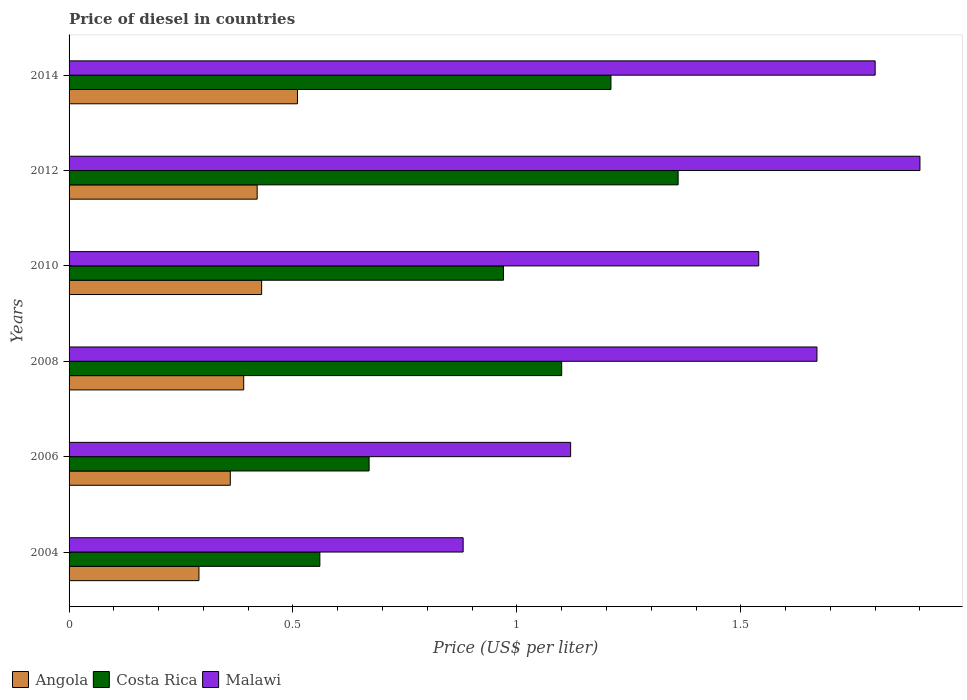How many different coloured bars are there?
Your response must be concise. 3. How many groups of bars are there?
Provide a succinct answer. 6. Are the number of bars per tick equal to the number of legend labels?
Give a very brief answer. Yes. Are the number of bars on each tick of the Y-axis equal?
Make the answer very short. Yes. How many bars are there on the 3rd tick from the bottom?
Your answer should be compact. 3. What is the label of the 4th group of bars from the top?
Provide a short and direct response. 2008. In how many cases, is the number of bars for a given year not equal to the number of legend labels?
Offer a terse response. 0. What is the price of diesel in Malawi in 2010?
Your response must be concise. 1.54. Across all years, what is the maximum price of diesel in Angola?
Offer a very short reply. 0.51. In which year was the price of diesel in Angola maximum?
Provide a succinct answer. 2014. What is the total price of diesel in Angola in the graph?
Offer a terse response. 2.4. What is the difference between the price of diesel in Malawi in 2006 and that in 2012?
Offer a very short reply. -0.78. What is the difference between the price of diesel in Malawi in 2006 and the price of diesel in Angola in 2010?
Make the answer very short. 0.69. What is the average price of diesel in Costa Rica per year?
Offer a very short reply. 0.98. In the year 2014, what is the difference between the price of diesel in Malawi and price of diesel in Costa Rica?
Give a very brief answer. 0.59. What is the ratio of the price of diesel in Costa Rica in 2008 to that in 2010?
Make the answer very short. 1.13. Is the price of diesel in Angola in 2004 less than that in 2012?
Your answer should be very brief. Yes. What is the difference between the highest and the second highest price of diesel in Malawi?
Provide a short and direct response. 0.1. In how many years, is the price of diesel in Angola greater than the average price of diesel in Angola taken over all years?
Offer a very short reply. 3. Is the sum of the price of diesel in Costa Rica in 2004 and 2006 greater than the maximum price of diesel in Angola across all years?
Provide a succinct answer. Yes. What does the 3rd bar from the top in 2004 represents?
Your answer should be compact. Angola. What does the 2nd bar from the bottom in 2012 represents?
Keep it short and to the point. Costa Rica. Is it the case that in every year, the sum of the price of diesel in Costa Rica and price of diesel in Angola is greater than the price of diesel in Malawi?
Give a very brief answer. No. How many bars are there?
Keep it short and to the point. 18. How many years are there in the graph?
Provide a short and direct response. 6. Are the values on the major ticks of X-axis written in scientific E-notation?
Offer a very short reply. No. Does the graph contain grids?
Provide a short and direct response. No. Where does the legend appear in the graph?
Provide a succinct answer. Bottom left. What is the title of the graph?
Make the answer very short. Price of diesel in countries. Does "Low & middle income" appear as one of the legend labels in the graph?
Give a very brief answer. No. What is the label or title of the X-axis?
Provide a short and direct response. Price (US$ per liter). What is the Price (US$ per liter) of Angola in 2004?
Provide a short and direct response. 0.29. What is the Price (US$ per liter) in Costa Rica in 2004?
Keep it short and to the point. 0.56. What is the Price (US$ per liter) of Malawi in 2004?
Keep it short and to the point. 0.88. What is the Price (US$ per liter) in Angola in 2006?
Keep it short and to the point. 0.36. What is the Price (US$ per liter) in Costa Rica in 2006?
Your answer should be compact. 0.67. What is the Price (US$ per liter) in Malawi in 2006?
Provide a succinct answer. 1.12. What is the Price (US$ per liter) of Angola in 2008?
Your answer should be compact. 0.39. What is the Price (US$ per liter) in Malawi in 2008?
Provide a succinct answer. 1.67. What is the Price (US$ per liter) of Angola in 2010?
Your response must be concise. 0.43. What is the Price (US$ per liter) in Malawi in 2010?
Offer a terse response. 1.54. What is the Price (US$ per liter) in Angola in 2012?
Your response must be concise. 0.42. What is the Price (US$ per liter) of Costa Rica in 2012?
Keep it short and to the point. 1.36. What is the Price (US$ per liter) in Angola in 2014?
Make the answer very short. 0.51. What is the Price (US$ per liter) of Costa Rica in 2014?
Offer a terse response. 1.21. What is the Price (US$ per liter) in Malawi in 2014?
Give a very brief answer. 1.8. Across all years, what is the maximum Price (US$ per liter) in Angola?
Your answer should be very brief. 0.51. Across all years, what is the maximum Price (US$ per liter) of Costa Rica?
Provide a short and direct response. 1.36. Across all years, what is the minimum Price (US$ per liter) in Angola?
Ensure brevity in your answer.  0.29. Across all years, what is the minimum Price (US$ per liter) of Costa Rica?
Provide a short and direct response. 0.56. Across all years, what is the minimum Price (US$ per liter) in Malawi?
Provide a succinct answer. 0.88. What is the total Price (US$ per liter) in Angola in the graph?
Your answer should be very brief. 2.4. What is the total Price (US$ per liter) in Costa Rica in the graph?
Your answer should be very brief. 5.87. What is the total Price (US$ per liter) of Malawi in the graph?
Give a very brief answer. 8.91. What is the difference between the Price (US$ per liter) of Angola in 2004 and that in 2006?
Offer a terse response. -0.07. What is the difference between the Price (US$ per liter) of Costa Rica in 2004 and that in 2006?
Provide a short and direct response. -0.11. What is the difference between the Price (US$ per liter) of Malawi in 2004 and that in 2006?
Keep it short and to the point. -0.24. What is the difference between the Price (US$ per liter) of Angola in 2004 and that in 2008?
Offer a terse response. -0.1. What is the difference between the Price (US$ per liter) of Costa Rica in 2004 and that in 2008?
Give a very brief answer. -0.54. What is the difference between the Price (US$ per liter) in Malawi in 2004 and that in 2008?
Provide a succinct answer. -0.79. What is the difference between the Price (US$ per liter) in Angola in 2004 and that in 2010?
Offer a terse response. -0.14. What is the difference between the Price (US$ per liter) in Costa Rica in 2004 and that in 2010?
Your answer should be compact. -0.41. What is the difference between the Price (US$ per liter) in Malawi in 2004 and that in 2010?
Your answer should be very brief. -0.66. What is the difference between the Price (US$ per liter) of Angola in 2004 and that in 2012?
Offer a very short reply. -0.13. What is the difference between the Price (US$ per liter) of Costa Rica in 2004 and that in 2012?
Keep it short and to the point. -0.8. What is the difference between the Price (US$ per liter) of Malawi in 2004 and that in 2012?
Make the answer very short. -1.02. What is the difference between the Price (US$ per liter) of Angola in 2004 and that in 2014?
Ensure brevity in your answer.  -0.22. What is the difference between the Price (US$ per liter) in Costa Rica in 2004 and that in 2014?
Your answer should be compact. -0.65. What is the difference between the Price (US$ per liter) of Malawi in 2004 and that in 2014?
Offer a very short reply. -0.92. What is the difference between the Price (US$ per liter) in Angola in 2006 and that in 2008?
Your response must be concise. -0.03. What is the difference between the Price (US$ per liter) in Costa Rica in 2006 and that in 2008?
Keep it short and to the point. -0.43. What is the difference between the Price (US$ per liter) in Malawi in 2006 and that in 2008?
Make the answer very short. -0.55. What is the difference between the Price (US$ per liter) of Angola in 2006 and that in 2010?
Make the answer very short. -0.07. What is the difference between the Price (US$ per liter) in Costa Rica in 2006 and that in 2010?
Ensure brevity in your answer.  -0.3. What is the difference between the Price (US$ per liter) in Malawi in 2006 and that in 2010?
Offer a very short reply. -0.42. What is the difference between the Price (US$ per liter) of Angola in 2006 and that in 2012?
Make the answer very short. -0.06. What is the difference between the Price (US$ per liter) of Costa Rica in 2006 and that in 2012?
Provide a short and direct response. -0.69. What is the difference between the Price (US$ per liter) of Malawi in 2006 and that in 2012?
Your answer should be compact. -0.78. What is the difference between the Price (US$ per liter) of Costa Rica in 2006 and that in 2014?
Give a very brief answer. -0.54. What is the difference between the Price (US$ per liter) in Malawi in 2006 and that in 2014?
Make the answer very short. -0.68. What is the difference between the Price (US$ per liter) of Angola in 2008 and that in 2010?
Offer a very short reply. -0.04. What is the difference between the Price (US$ per liter) in Costa Rica in 2008 and that in 2010?
Make the answer very short. 0.13. What is the difference between the Price (US$ per liter) in Malawi in 2008 and that in 2010?
Offer a very short reply. 0.13. What is the difference between the Price (US$ per liter) in Angola in 2008 and that in 2012?
Provide a short and direct response. -0.03. What is the difference between the Price (US$ per liter) in Costa Rica in 2008 and that in 2012?
Your answer should be very brief. -0.26. What is the difference between the Price (US$ per liter) in Malawi in 2008 and that in 2012?
Your response must be concise. -0.23. What is the difference between the Price (US$ per liter) of Angola in 2008 and that in 2014?
Your answer should be compact. -0.12. What is the difference between the Price (US$ per liter) of Costa Rica in 2008 and that in 2014?
Provide a short and direct response. -0.11. What is the difference between the Price (US$ per liter) of Malawi in 2008 and that in 2014?
Offer a very short reply. -0.13. What is the difference between the Price (US$ per liter) in Angola in 2010 and that in 2012?
Your answer should be compact. 0.01. What is the difference between the Price (US$ per liter) of Costa Rica in 2010 and that in 2012?
Ensure brevity in your answer.  -0.39. What is the difference between the Price (US$ per liter) of Malawi in 2010 and that in 2012?
Ensure brevity in your answer.  -0.36. What is the difference between the Price (US$ per liter) in Angola in 2010 and that in 2014?
Give a very brief answer. -0.08. What is the difference between the Price (US$ per liter) of Costa Rica in 2010 and that in 2014?
Make the answer very short. -0.24. What is the difference between the Price (US$ per liter) in Malawi in 2010 and that in 2014?
Your response must be concise. -0.26. What is the difference between the Price (US$ per liter) of Angola in 2012 and that in 2014?
Offer a very short reply. -0.09. What is the difference between the Price (US$ per liter) in Costa Rica in 2012 and that in 2014?
Ensure brevity in your answer.  0.15. What is the difference between the Price (US$ per liter) of Malawi in 2012 and that in 2014?
Keep it short and to the point. 0.1. What is the difference between the Price (US$ per liter) in Angola in 2004 and the Price (US$ per liter) in Costa Rica in 2006?
Provide a short and direct response. -0.38. What is the difference between the Price (US$ per liter) in Angola in 2004 and the Price (US$ per liter) in Malawi in 2006?
Ensure brevity in your answer.  -0.83. What is the difference between the Price (US$ per liter) in Costa Rica in 2004 and the Price (US$ per liter) in Malawi in 2006?
Your response must be concise. -0.56. What is the difference between the Price (US$ per liter) in Angola in 2004 and the Price (US$ per liter) in Costa Rica in 2008?
Your answer should be very brief. -0.81. What is the difference between the Price (US$ per liter) in Angola in 2004 and the Price (US$ per liter) in Malawi in 2008?
Your response must be concise. -1.38. What is the difference between the Price (US$ per liter) in Costa Rica in 2004 and the Price (US$ per liter) in Malawi in 2008?
Your answer should be compact. -1.11. What is the difference between the Price (US$ per liter) of Angola in 2004 and the Price (US$ per liter) of Costa Rica in 2010?
Ensure brevity in your answer.  -0.68. What is the difference between the Price (US$ per liter) of Angola in 2004 and the Price (US$ per liter) of Malawi in 2010?
Ensure brevity in your answer.  -1.25. What is the difference between the Price (US$ per liter) of Costa Rica in 2004 and the Price (US$ per liter) of Malawi in 2010?
Ensure brevity in your answer.  -0.98. What is the difference between the Price (US$ per liter) of Angola in 2004 and the Price (US$ per liter) of Costa Rica in 2012?
Make the answer very short. -1.07. What is the difference between the Price (US$ per liter) of Angola in 2004 and the Price (US$ per liter) of Malawi in 2012?
Your answer should be compact. -1.61. What is the difference between the Price (US$ per liter) in Costa Rica in 2004 and the Price (US$ per liter) in Malawi in 2012?
Your answer should be compact. -1.34. What is the difference between the Price (US$ per liter) in Angola in 2004 and the Price (US$ per liter) in Costa Rica in 2014?
Provide a short and direct response. -0.92. What is the difference between the Price (US$ per liter) of Angola in 2004 and the Price (US$ per liter) of Malawi in 2014?
Provide a succinct answer. -1.51. What is the difference between the Price (US$ per liter) in Costa Rica in 2004 and the Price (US$ per liter) in Malawi in 2014?
Make the answer very short. -1.24. What is the difference between the Price (US$ per liter) of Angola in 2006 and the Price (US$ per liter) of Costa Rica in 2008?
Make the answer very short. -0.74. What is the difference between the Price (US$ per liter) in Angola in 2006 and the Price (US$ per liter) in Malawi in 2008?
Your response must be concise. -1.31. What is the difference between the Price (US$ per liter) of Angola in 2006 and the Price (US$ per liter) of Costa Rica in 2010?
Your answer should be compact. -0.61. What is the difference between the Price (US$ per liter) of Angola in 2006 and the Price (US$ per liter) of Malawi in 2010?
Your answer should be compact. -1.18. What is the difference between the Price (US$ per liter) of Costa Rica in 2006 and the Price (US$ per liter) of Malawi in 2010?
Keep it short and to the point. -0.87. What is the difference between the Price (US$ per liter) of Angola in 2006 and the Price (US$ per liter) of Costa Rica in 2012?
Your answer should be compact. -1. What is the difference between the Price (US$ per liter) of Angola in 2006 and the Price (US$ per liter) of Malawi in 2012?
Keep it short and to the point. -1.54. What is the difference between the Price (US$ per liter) of Costa Rica in 2006 and the Price (US$ per liter) of Malawi in 2012?
Keep it short and to the point. -1.23. What is the difference between the Price (US$ per liter) in Angola in 2006 and the Price (US$ per liter) in Costa Rica in 2014?
Offer a very short reply. -0.85. What is the difference between the Price (US$ per liter) of Angola in 2006 and the Price (US$ per liter) of Malawi in 2014?
Your answer should be compact. -1.44. What is the difference between the Price (US$ per liter) of Costa Rica in 2006 and the Price (US$ per liter) of Malawi in 2014?
Offer a terse response. -1.13. What is the difference between the Price (US$ per liter) in Angola in 2008 and the Price (US$ per liter) in Costa Rica in 2010?
Make the answer very short. -0.58. What is the difference between the Price (US$ per liter) of Angola in 2008 and the Price (US$ per liter) of Malawi in 2010?
Offer a terse response. -1.15. What is the difference between the Price (US$ per liter) of Costa Rica in 2008 and the Price (US$ per liter) of Malawi in 2010?
Keep it short and to the point. -0.44. What is the difference between the Price (US$ per liter) in Angola in 2008 and the Price (US$ per liter) in Costa Rica in 2012?
Offer a terse response. -0.97. What is the difference between the Price (US$ per liter) of Angola in 2008 and the Price (US$ per liter) of Malawi in 2012?
Ensure brevity in your answer.  -1.51. What is the difference between the Price (US$ per liter) in Angola in 2008 and the Price (US$ per liter) in Costa Rica in 2014?
Keep it short and to the point. -0.82. What is the difference between the Price (US$ per liter) of Angola in 2008 and the Price (US$ per liter) of Malawi in 2014?
Provide a short and direct response. -1.41. What is the difference between the Price (US$ per liter) in Angola in 2010 and the Price (US$ per liter) in Costa Rica in 2012?
Ensure brevity in your answer.  -0.93. What is the difference between the Price (US$ per liter) in Angola in 2010 and the Price (US$ per liter) in Malawi in 2012?
Your response must be concise. -1.47. What is the difference between the Price (US$ per liter) in Costa Rica in 2010 and the Price (US$ per liter) in Malawi in 2012?
Offer a terse response. -0.93. What is the difference between the Price (US$ per liter) of Angola in 2010 and the Price (US$ per liter) of Costa Rica in 2014?
Your response must be concise. -0.78. What is the difference between the Price (US$ per liter) in Angola in 2010 and the Price (US$ per liter) in Malawi in 2014?
Provide a short and direct response. -1.37. What is the difference between the Price (US$ per liter) of Costa Rica in 2010 and the Price (US$ per liter) of Malawi in 2014?
Provide a succinct answer. -0.83. What is the difference between the Price (US$ per liter) of Angola in 2012 and the Price (US$ per liter) of Costa Rica in 2014?
Make the answer very short. -0.79. What is the difference between the Price (US$ per liter) of Angola in 2012 and the Price (US$ per liter) of Malawi in 2014?
Offer a terse response. -1.38. What is the difference between the Price (US$ per liter) in Costa Rica in 2012 and the Price (US$ per liter) in Malawi in 2014?
Keep it short and to the point. -0.44. What is the average Price (US$ per liter) in Angola per year?
Offer a terse response. 0.4. What is the average Price (US$ per liter) in Costa Rica per year?
Make the answer very short. 0.98. What is the average Price (US$ per liter) of Malawi per year?
Offer a very short reply. 1.49. In the year 2004, what is the difference between the Price (US$ per liter) of Angola and Price (US$ per liter) of Costa Rica?
Keep it short and to the point. -0.27. In the year 2004, what is the difference between the Price (US$ per liter) in Angola and Price (US$ per liter) in Malawi?
Make the answer very short. -0.59. In the year 2004, what is the difference between the Price (US$ per liter) in Costa Rica and Price (US$ per liter) in Malawi?
Your response must be concise. -0.32. In the year 2006, what is the difference between the Price (US$ per liter) of Angola and Price (US$ per liter) of Costa Rica?
Your answer should be very brief. -0.31. In the year 2006, what is the difference between the Price (US$ per liter) of Angola and Price (US$ per liter) of Malawi?
Your response must be concise. -0.76. In the year 2006, what is the difference between the Price (US$ per liter) of Costa Rica and Price (US$ per liter) of Malawi?
Make the answer very short. -0.45. In the year 2008, what is the difference between the Price (US$ per liter) in Angola and Price (US$ per liter) in Costa Rica?
Provide a succinct answer. -0.71. In the year 2008, what is the difference between the Price (US$ per liter) in Angola and Price (US$ per liter) in Malawi?
Your answer should be compact. -1.28. In the year 2008, what is the difference between the Price (US$ per liter) in Costa Rica and Price (US$ per liter) in Malawi?
Give a very brief answer. -0.57. In the year 2010, what is the difference between the Price (US$ per liter) in Angola and Price (US$ per liter) in Costa Rica?
Offer a very short reply. -0.54. In the year 2010, what is the difference between the Price (US$ per liter) of Angola and Price (US$ per liter) of Malawi?
Your answer should be very brief. -1.11. In the year 2010, what is the difference between the Price (US$ per liter) of Costa Rica and Price (US$ per liter) of Malawi?
Give a very brief answer. -0.57. In the year 2012, what is the difference between the Price (US$ per liter) in Angola and Price (US$ per liter) in Costa Rica?
Make the answer very short. -0.94. In the year 2012, what is the difference between the Price (US$ per liter) of Angola and Price (US$ per liter) of Malawi?
Keep it short and to the point. -1.48. In the year 2012, what is the difference between the Price (US$ per liter) in Costa Rica and Price (US$ per liter) in Malawi?
Provide a succinct answer. -0.54. In the year 2014, what is the difference between the Price (US$ per liter) in Angola and Price (US$ per liter) in Costa Rica?
Provide a short and direct response. -0.7. In the year 2014, what is the difference between the Price (US$ per liter) in Angola and Price (US$ per liter) in Malawi?
Your answer should be very brief. -1.29. In the year 2014, what is the difference between the Price (US$ per liter) of Costa Rica and Price (US$ per liter) of Malawi?
Your answer should be compact. -0.59. What is the ratio of the Price (US$ per liter) of Angola in 2004 to that in 2006?
Keep it short and to the point. 0.81. What is the ratio of the Price (US$ per liter) of Costa Rica in 2004 to that in 2006?
Your answer should be compact. 0.84. What is the ratio of the Price (US$ per liter) of Malawi in 2004 to that in 2006?
Your answer should be compact. 0.79. What is the ratio of the Price (US$ per liter) in Angola in 2004 to that in 2008?
Make the answer very short. 0.74. What is the ratio of the Price (US$ per liter) of Costa Rica in 2004 to that in 2008?
Offer a terse response. 0.51. What is the ratio of the Price (US$ per liter) of Malawi in 2004 to that in 2008?
Give a very brief answer. 0.53. What is the ratio of the Price (US$ per liter) of Angola in 2004 to that in 2010?
Ensure brevity in your answer.  0.67. What is the ratio of the Price (US$ per liter) of Costa Rica in 2004 to that in 2010?
Your answer should be very brief. 0.58. What is the ratio of the Price (US$ per liter) of Angola in 2004 to that in 2012?
Offer a very short reply. 0.69. What is the ratio of the Price (US$ per liter) in Costa Rica in 2004 to that in 2012?
Provide a short and direct response. 0.41. What is the ratio of the Price (US$ per liter) in Malawi in 2004 to that in 2012?
Your answer should be very brief. 0.46. What is the ratio of the Price (US$ per liter) in Angola in 2004 to that in 2014?
Keep it short and to the point. 0.57. What is the ratio of the Price (US$ per liter) in Costa Rica in 2004 to that in 2014?
Offer a very short reply. 0.46. What is the ratio of the Price (US$ per liter) in Malawi in 2004 to that in 2014?
Your answer should be compact. 0.49. What is the ratio of the Price (US$ per liter) of Angola in 2006 to that in 2008?
Keep it short and to the point. 0.92. What is the ratio of the Price (US$ per liter) in Costa Rica in 2006 to that in 2008?
Your answer should be compact. 0.61. What is the ratio of the Price (US$ per liter) in Malawi in 2006 to that in 2008?
Make the answer very short. 0.67. What is the ratio of the Price (US$ per liter) of Angola in 2006 to that in 2010?
Provide a succinct answer. 0.84. What is the ratio of the Price (US$ per liter) of Costa Rica in 2006 to that in 2010?
Your response must be concise. 0.69. What is the ratio of the Price (US$ per liter) in Malawi in 2006 to that in 2010?
Your response must be concise. 0.73. What is the ratio of the Price (US$ per liter) in Angola in 2006 to that in 2012?
Make the answer very short. 0.86. What is the ratio of the Price (US$ per liter) in Costa Rica in 2006 to that in 2012?
Keep it short and to the point. 0.49. What is the ratio of the Price (US$ per liter) of Malawi in 2006 to that in 2012?
Provide a succinct answer. 0.59. What is the ratio of the Price (US$ per liter) in Angola in 2006 to that in 2014?
Provide a succinct answer. 0.71. What is the ratio of the Price (US$ per liter) of Costa Rica in 2006 to that in 2014?
Your answer should be compact. 0.55. What is the ratio of the Price (US$ per liter) in Malawi in 2006 to that in 2014?
Your answer should be very brief. 0.62. What is the ratio of the Price (US$ per liter) of Angola in 2008 to that in 2010?
Your response must be concise. 0.91. What is the ratio of the Price (US$ per liter) in Costa Rica in 2008 to that in 2010?
Give a very brief answer. 1.13. What is the ratio of the Price (US$ per liter) of Malawi in 2008 to that in 2010?
Offer a terse response. 1.08. What is the ratio of the Price (US$ per liter) in Angola in 2008 to that in 2012?
Make the answer very short. 0.93. What is the ratio of the Price (US$ per liter) in Costa Rica in 2008 to that in 2012?
Keep it short and to the point. 0.81. What is the ratio of the Price (US$ per liter) in Malawi in 2008 to that in 2012?
Offer a very short reply. 0.88. What is the ratio of the Price (US$ per liter) of Angola in 2008 to that in 2014?
Your answer should be very brief. 0.76. What is the ratio of the Price (US$ per liter) in Costa Rica in 2008 to that in 2014?
Provide a short and direct response. 0.91. What is the ratio of the Price (US$ per liter) of Malawi in 2008 to that in 2014?
Your answer should be very brief. 0.93. What is the ratio of the Price (US$ per liter) in Angola in 2010 to that in 2012?
Your answer should be very brief. 1.02. What is the ratio of the Price (US$ per liter) in Costa Rica in 2010 to that in 2012?
Give a very brief answer. 0.71. What is the ratio of the Price (US$ per liter) in Malawi in 2010 to that in 2012?
Provide a succinct answer. 0.81. What is the ratio of the Price (US$ per liter) in Angola in 2010 to that in 2014?
Offer a terse response. 0.84. What is the ratio of the Price (US$ per liter) in Costa Rica in 2010 to that in 2014?
Keep it short and to the point. 0.8. What is the ratio of the Price (US$ per liter) of Malawi in 2010 to that in 2014?
Offer a terse response. 0.86. What is the ratio of the Price (US$ per liter) of Angola in 2012 to that in 2014?
Offer a very short reply. 0.82. What is the ratio of the Price (US$ per liter) in Costa Rica in 2012 to that in 2014?
Provide a succinct answer. 1.12. What is the ratio of the Price (US$ per liter) of Malawi in 2012 to that in 2014?
Ensure brevity in your answer.  1.06. What is the difference between the highest and the second highest Price (US$ per liter) of Angola?
Provide a short and direct response. 0.08. What is the difference between the highest and the second highest Price (US$ per liter) in Costa Rica?
Offer a terse response. 0.15. What is the difference between the highest and the lowest Price (US$ per liter) in Angola?
Keep it short and to the point. 0.22. What is the difference between the highest and the lowest Price (US$ per liter) in Malawi?
Give a very brief answer. 1.02. 